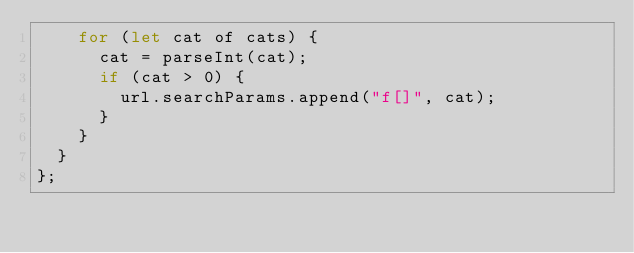<code> <loc_0><loc_0><loc_500><loc_500><_JavaScript_>    for (let cat of cats) {
      cat = parseInt(cat);
      if (cat > 0) {
        url.searchParams.append("f[]", cat);
      }
    }
  }
};
</code> 